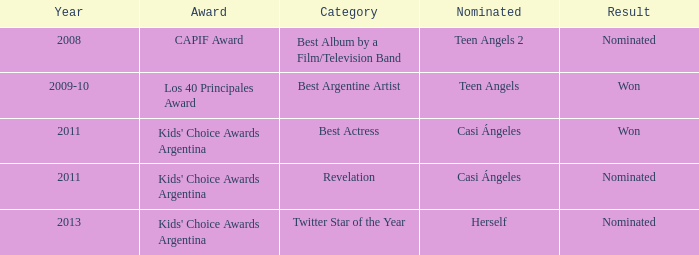For which prize was there a nomination for leading actress? Kids' Choice Awards Argentina. 